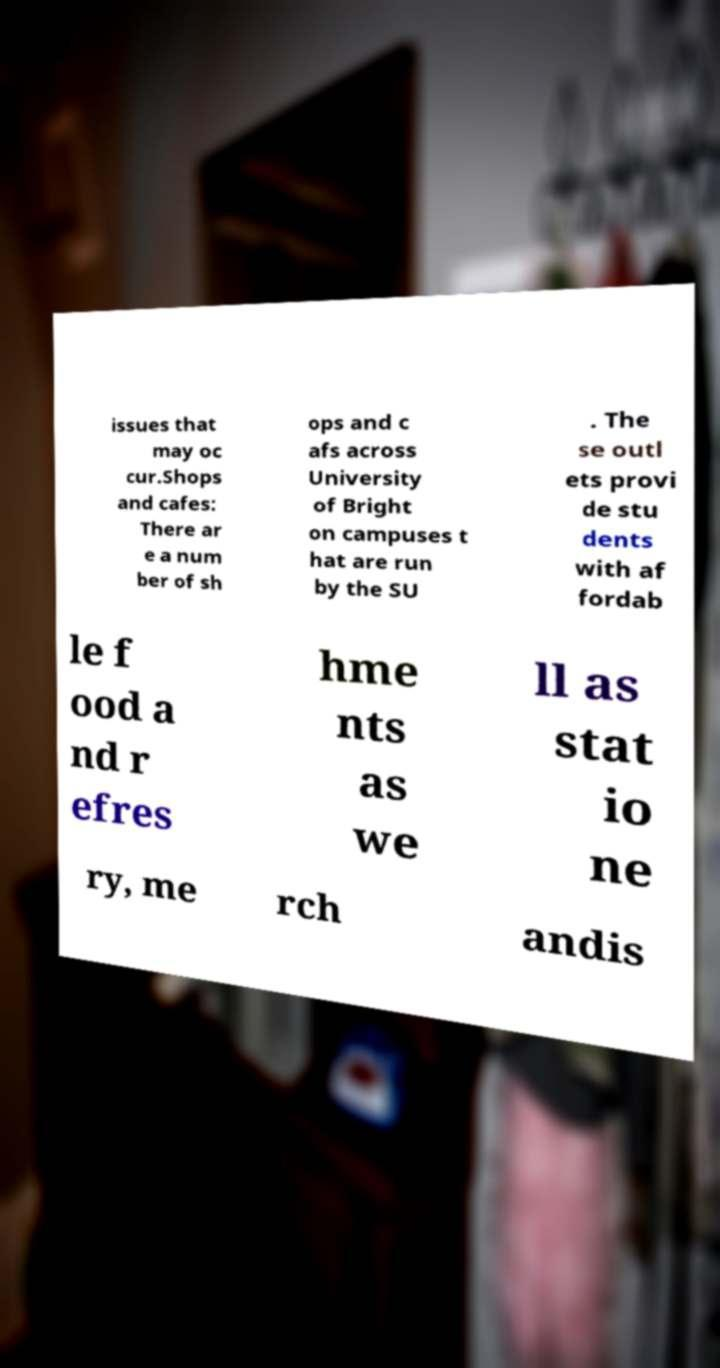Please identify and transcribe the text found in this image. issues that may oc cur.Shops and cafes: There ar e a num ber of sh ops and c afs across University of Bright on campuses t hat are run by the SU . The se outl ets provi de stu dents with af fordab le f ood a nd r efres hme nts as we ll as stat io ne ry, me rch andis 